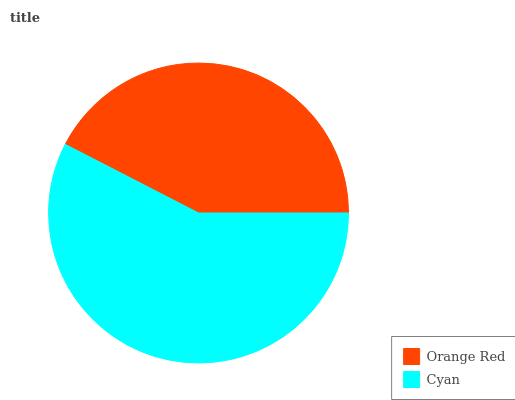Is Orange Red the minimum?
Answer yes or no. Yes. Is Cyan the maximum?
Answer yes or no. Yes. Is Cyan the minimum?
Answer yes or no. No. Is Cyan greater than Orange Red?
Answer yes or no. Yes. Is Orange Red less than Cyan?
Answer yes or no. Yes. Is Orange Red greater than Cyan?
Answer yes or no. No. Is Cyan less than Orange Red?
Answer yes or no. No. Is Cyan the high median?
Answer yes or no. Yes. Is Orange Red the low median?
Answer yes or no. Yes. Is Orange Red the high median?
Answer yes or no. No. Is Cyan the low median?
Answer yes or no. No. 